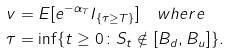<formula> <loc_0><loc_0><loc_500><loc_500>v & = E [ e ^ { - \alpha _ { T } } I _ { \{ \tau \geq T \} } ] \quad w h e r e \\ \tau & = \inf \{ t \geq 0 \colon S _ { t } \notin [ B _ { d } , B _ { u } ] \} .</formula> 